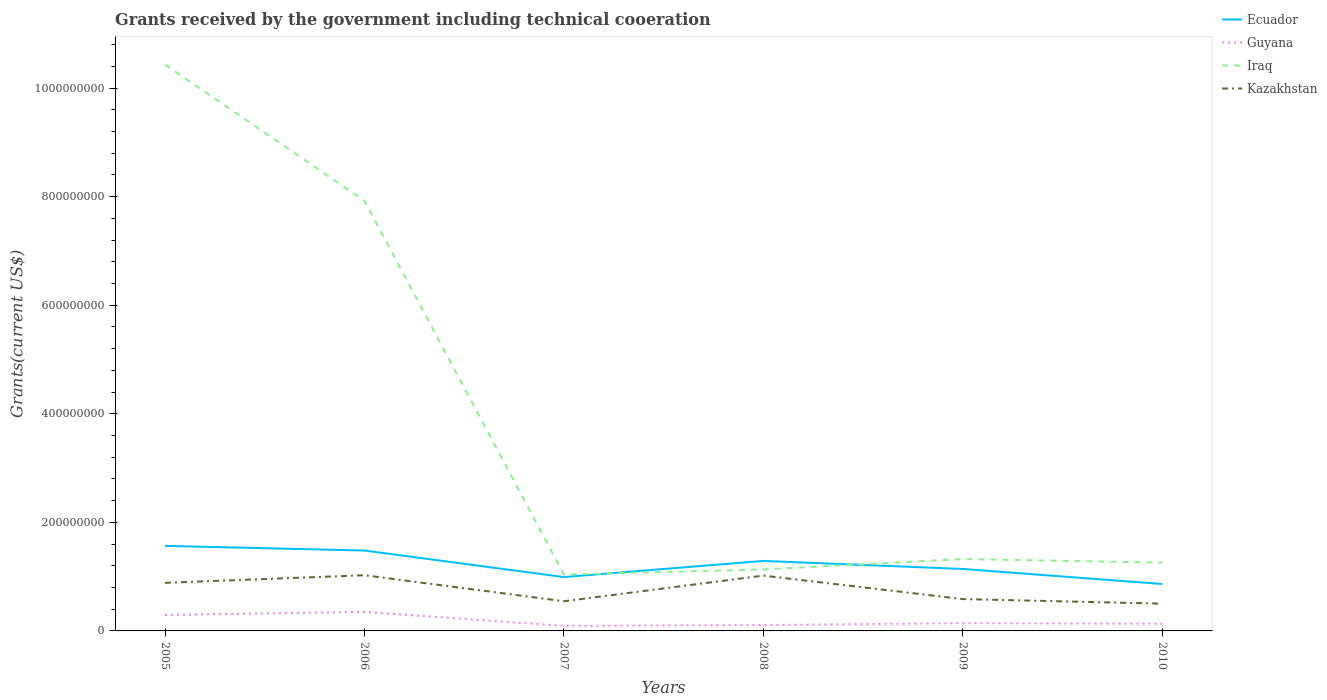How many different coloured lines are there?
Give a very brief answer. 4. Is the number of lines equal to the number of legend labels?
Ensure brevity in your answer.  Yes. Across all years, what is the maximum total grants received by the government in Iraq?
Offer a terse response. 1.04e+08. What is the total total grants received by the government in Ecuador in the graph?
Offer a terse response. 1.48e+07. What is the difference between the highest and the second highest total grants received by the government in Ecuador?
Offer a terse response. 7.02e+07. How many years are there in the graph?
Ensure brevity in your answer.  6. What is the difference between two consecutive major ticks on the Y-axis?
Provide a short and direct response. 2.00e+08. Are the values on the major ticks of Y-axis written in scientific E-notation?
Make the answer very short. No. Does the graph contain any zero values?
Your answer should be very brief. No. Does the graph contain grids?
Offer a very short reply. No. How many legend labels are there?
Keep it short and to the point. 4. How are the legend labels stacked?
Offer a very short reply. Vertical. What is the title of the graph?
Offer a very short reply. Grants received by the government including technical cooeration. Does "Macedonia" appear as one of the legend labels in the graph?
Your response must be concise. No. What is the label or title of the Y-axis?
Your answer should be compact. Grants(current US$). What is the Grants(current US$) in Ecuador in 2005?
Your answer should be very brief. 1.57e+08. What is the Grants(current US$) in Guyana in 2005?
Provide a succinct answer. 2.94e+07. What is the Grants(current US$) in Iraq in 2005?
Keep it short and to the point. 1.04e+09. What is the Grants(current US$) in Kazakhstan in 2005?
Make the answer very short. 8.86e+07. What is the Grants(current US$) of Ecuador in 2006?
Provide a succinct answer. 1.48e+08. What is the Grants(current US$) in Guyana in 2006?
Offer a very short reply. 3.50e+07. What is the Grants(current US$) of Iraq in 2006?
Offer a terse response. 7.92e+08. What is the Grants(current US$) of Kazakhstan in 2006?
Your answer should be very brief. 1.03e+08. What is the Grants(current US$) in Ecuador in 2007?
Offer a very short reply. 9.92e+07. What is the Grants(current US$) of Guyana in 2007?
Make the answer very short. 9.26e+06. What is the Grants(current US$) of Iraq in 2007?
Provide a succinct answer. 1.04e+08. What is the Grants(current US$) of Kazakhstan in 2007?
Offer a terse response. 5.46e+07. What is the Grants(current US$) in Ecuador in 2008?
Your answer should be very brief. 1.29e+08. What is the Grants(current US$) of Guyana in 2008?
Provide a succinct answer. 1.08e+07. What is the Grants(current US$) in Iraq in 2008?
Your response must be concise. 1.13e+08. What is the Grants(current US$) in Kazakhstan in 2008?
Your answer should be very brief. 1.02e+08. What is the Grants(current US$) of Ecuador in 2009?
Provide a short and direct response. 1.14e+08. What is the Grants(current US$) in Guyana in 2009?
Your answer should be compact. 1.42e+07. What is the Grants(current US$) in Iraq in 2009?
Your answer should be very brief. 1.32e+08. What is the Grants(current US$) of Kazakhstan in 2009?
Ensure brevity in your answer.  5.87e+07. What is the Grants(current US$) in Ecuador in 2010?
Offer a terse response. 8.64e+07. What is the Grants(current US$) of Guyana in 2010?
Keep it short and to the point. 1.32e+07. What is the Grants(current US$) of Iraq in 2010?
Your answer should be very brief. 1.26e+08. What is the Grants(current US$) of Kazakhstan in 2010?
Your answer should be compact. 5.02e+07. Across all years, what is the maximum Grants(current US$) of Ecuador?
Provide a short and direct response. 1.57e+08. Across all years, what is the maximum Grants(current US$) in Guyana?
Your answer should be very brief. 3.50e+07. Across all years, what is the maximum Grants(current US$) of Iraq?
Offer a very short reply. 1.04e+09. Across all years, what is the maximum Grants(current US$) of Kazakhstan?
Your answer should be compact. 1.03e+08. Across all years, what is the minimum Grants(current US$) of Ecuador?
Give a very brief answer. 8.64e+07. Across all years, what is the minimum Grants(current US$) of Guyana?
Offer a terse response. 9.26e+06. Across all years, what is the minimum Grants(current US$) in Iraq?
Give a very brief answer. 1.04e+08. Across all years, what is the minimum Grants(current US$) of Kazakhstan?
Give a very brief answer. 5.02e+07. What is the total Grants(current US$) in Ecuador in the graph?
Provide a short and direct response. 7.33e+08. What is the total Grants(current US$) of Guyana in the graph?
Your answer should be very brief. 1.12e+08. What is the total Grants(current US$) in Iraq in the graph?
Make the answer very short. 2.31e+09. What is the total Grants(current US$) of Kazakhstan in the graph?
Your answer should be compact. 4.57e+08. What is the difference between the Grants(current US$) in Ecuador in 2005 and that in 2006?
Offer a very short reply. 8.58e+06. What is the difference between the Grants(current US$) in Guyana in 2005 and that in 2006?
Give a very brief answer. -5.61e+06. What is the difference between the Grants(current US$) in Iraq in 2005 and that in 2006?
Offer a terse response. 2.51e+08. What is the difference between the Grants(current US$) in Kazakhstan in 2005 and that in 2006?
Keep it short and to the point. -1.40e+07. What is the difference between the Grants(current US$) in Ecuador in 2005 and that in 2007?
Ensure brevity in your answer.  5.75e+07. What is the difference between the Grants(current US$) of Guyana in 2005 and that in 2007?
Keep it short and to the point. 2.02e+07. What is the difference between the Grants(current US$) in Iraq in 2005 and that in 2007?
Keep it short and to the point. 9.39e+08. What is the difference between the Grants(current US$) in Kazakhstan in 2005 and that in 2007?
Your answer should be compact. 3.39e+07. What is the difference between the Grants(current US$) of Ecuador in 2005 and that in 2008?
Your response must be concise. 2.77e+07. What is the difference between the Grants(current US$) in Guyana in 2005 and that in 2008?
Provide a succinct answer. 1.86e+07. What is the difference between the Grants(current US$) of Iraq in 2005 and that in 2008?
Provide a short and direct response. 9.30e+08. What is the difference between the Grants(current US$) of Kazakhstan in 2005 and that in 2008?
Your answer should be very brief. -1.33e+07. What is the difference between the Grants(current US$) of Ecuador in 2005 and that in 2009?
Offer a very short reply. 4.25e+07. What is the difference between the Grants(current US$) in Guyana in 2005 and that in 2009?
Keep it short and to the point. 1.52e+07. What is the difference between the Grants(current US$) of Iraq in 2005 and that in 2009?
Your answer should be very brief. 9.11e+08. What is the difference between the Grants(current US$) of Kazakhstan in 2005 and that in 2009?
Provide a succinct answer. 2.99e+07. What is the difference between the Grants(current US$) in Ecuador in 2005 and that in 2010?
Ensure brevity in your answer.  7.02e+07. What is the difference between the Grants(current US$) of Guyana in 2005 and that in 2010?
Make the answer very short. 1.62e+07. What is the difference between the Grants(current US$) in Iraq in 2005 and that in 2010?
Provide a succinct answer. 9.17e+08. What is the difference between the Grants(current US$) in Kazakhstan in 2005 and that in 2010?
Offer a very short reply. 3.83e+07. What is the difference between the Grants(current US$) of Ecuador in 2006 and that in 2007?
Your answer should be compact. 4.89e+07. What is the difference between the Grants(current US$) in Guyana in 2006 and that in 2007?
Your answer should be very brief. 2.58e+07. What is the difference between the Grants(current US$) of Iraq in 2006 and that in 2007?
Provide a short and direct response. 6.88e+08. What is the difference between the Grants(current US$) of Kazakhstan in 2006 and that in 2007?
Your answer should be very brief. 4.80e+07. What is the difference between the Grants(current US$) in Ecuador in 2006 and that in 2008?
Your response must be concise. 1.91e+07. What is the difference between the Grants(current US$) of Guyana in 2006 and that in 2008?
Ensure brevity in your answer.  2.42e+07. What is the difference between the Grants(current US$) of Iraq in 2006 and that in 2008?
Offer a very short reply. 6.79e+08. What is the difference between the Grants(current US$) of Kazakhstan in 2006 and that in 2008?
Provide a succinct answer. 6.80e+05. What is the difference between the Grants(current US$) of Ecuador in 2006 and that in 2009?
Ensure brevity in your answer.  3.40e+07. What is the difference between the Grants(current US$) in Guyana in 2006 and that in 2009?
Offer a terse response. 2.08e+07. What is the difference between the Grants(current US$) of Iraq in 2006 and that in 2009?
Provide a succinct answer. 6.60e+08. What is the difference between the Grants(current US$) in Kazakhstan in 2006 and that in 2009?
Provide a succinct answer. 4.39e+07. What is the difference between the Grants(current US$) in Ecuador in 2006 and that in 2010?
Offer a terse response. 6.16e+07. What is the difference between the Grants(current US$) of Guyana in 2006 and that in 2010?
Your response must be concise. 2.18e+07. What is the difference between the Grants(current US$) in Iraq in 2006 and that in 2010?
Make the answer very short. 6.66e+08. What is the difference between the Grants(current US$) of Kazakhstan in 2006 and that in 2010?
Make the answer very short. 5.24e+07. What is the difference between the Grants(current US$) in Ecuador in 2007 and that in 2008?
Make the answer very short. -2.97e+07. What is the difference between the Grants(current US$) of Guyana in 2007 and that in 2008?
Provide a succinct answer. -1.56e+06. What is the difference between the Grants(current US$) of Iraq in 2007 and that in 2008?
Your response must be concise. -9.33e+06. What is the difference between the Grants(current US$) of Kazakhstan in 2007 and that in 2008?
Your response must be concise. -4.73e+07. What is the difference between the Grants(current US$) of Ecuador in 2007 and that in 2009?
Provide a succinct answer. -1.49e+07. What is the difference between the Grants(current US$) in Guyana in 2007 and that in 2009?
Provide a succinct answer. -4.98e+06. What is the difference between the Grants(current US$) in Iraq in 2007 and that in 2009?
Keep it short and to the point. -2.85e+07. What is the difference between the Grants(current US$) in Kazakhstan in 2007 and that in 2009?
Provide a short and direct response. -4.04e+06. What is the difference between the Grants(current US$) in Ecuador in 2007 and that in 2010?
Make the answer very short. 1.28e+07. What is the difference between the Grants(current US$) of Guyana in 2007 and that in 2010?
Offer a very short reply. -3.94e+06. What is the difference between the Grants(current US$) in Iraq in 2007 and that in 2010?
Keep it short and to the point. -2.19e+07. What is the difference between the Grants(current US$) of Kazakhstan in 2007 and that in 2010?
Make the answer very short. 4.41e+06. What is the difference between the Grants(current US$) in Ecuador in 2008 and that in 2009?
Give a very brief answer. 1.48e+07. What is the difference between the Grants(current US$) in Guyana in 2008 and that in 2009?
Offer a very short reply. -3.42e+06. What is the difference between the Grants(current US$) of Iraq in 2008 and that in 2009?
Ensure brevity in your answer.  -1.92e+07. What is the difference between the Grants(current US$) of Kazakhstan in 2008 and that in 2009?
Give a very brief answer. 4.32e+07. What is the difference between the Grants(current US$) of Ecuador in 2008 and that in 2010?
Ensure brevity in your answer.  4.25e+07. What is the difference between the Grants(current US$) of Guyana in 2008 and that in 2010?
Give a very brief answer. -2.38e+06. What is the difference between the Grants(current US$) of Iraq in 2008 and that in 2010?
Give a very brief answer. -1.25e+07. What is the difference between the Grants(current US$) of Kazakhstan in 2008 and that in 2010?
Make the answer very short. 5.17e+07. What is the difference between the Grants(current US$) in Ecuador in 2009 and that in 2010?
Offer a very short reply. 2.77e+07. What is the difference between the Grants(current US$) of Guyana in 2009 and that in 2010?
Provide a succinct answer. 1.04e+06. What is the difference between the Grants(current US$) of Iraq in 2009 and that in 2010?
Provide a short and direct response. 6.61e+06. What is the difference between the Grants(current US$) of Kazakhstan in 2009 and that in 2010?
Ensure brevity in your answer.  8.45e+06. What is the difference between the Grants(current US$) in Ecuador in 2005 and the Grants(current US$) in Guyana in 2006?
Give a very brief answer. 1.22e+08. What is the difference between the Grants(current US$) of Ecuador in 2005 and the Grants(current US$) of Iraq in 2006?
Your answer should be very brief. -6.36e+08. What is the difference between the Grants(current US$) in Ecuador in 2005 and the Grants(current US$) in Kazakhstan in 2006?
Your answer should be compact. 5.41e+07. What is the difference between the Grants(current US$) of Guyana in 2005 and the Grants(current US$) of Iraq in 2006?
Offer a terse response. -7.63e+08. What is the difference between the Grants(current US$) of Guyana in 2005 and the Grants(current US$) of Kazakhstan in 2006?
Ensure brevity in your answer.  -7.32e+07. What is the difference between the Grants(current US$) of Iraq in 2005 and the Grants(current US$) of Kazakhstan in 2006?
Provide a short and direct response. 9.40e+08. What is the difference between the Grants(current US$) of Ecuador in 2005 and the Grants(current US$) of Guyana in 2007?
Give a very brief answer. 1.47e+08. What is the difference between the Grants(current US$) in Ecuador in 2005 and the Grants(current US$) in Iraq in 2007?
Your answer should be compact. 5.27e+07. What is the difference between the Grants(current US$) in Ecuador in 2005 and the Grants(current US$) in Kazakhstan in 2007?
Offer a very short reply. 1.02e+08. What is the difference between the Grants(current US$) in Guyana in 2005 and the Grants(current US$) in Iraq in 2007?
Make the answer very short. -7.45e+07. What is the difference between the Grants(current US$) in Guyana in 2005 and the Grants(current US$) in Kazakhstan in 2007?
Give a very brief answer. -2.52e+07. What is the difference between the Grants(current US$) of Iraq in 2005 and the Grants(current US$) of Kazakhstan in 2007?
Give a very brief answer. 9.88e+08. What is the difference between the Grants(current US$) of Ecuador in 2005 and the Grants(current US$) of Guyana in 2008?
Provide a succinct answer. 1.46e+08. What is the difference between the Grants(current US$) in Ecuador in 2005 and the Grants(current US$) in Iraq in 2008?
Provide a short and direct response. 4.34e+07. What is the difference between the Grants(current US$) in Ecuador in 2005 and the Grants(current US$) in Kazakhstan in 2008?
Your response must be concise. 5.48e+07. What is the difference between the Grants(current US$) in Guyana in 2005 and the Grants(current US$) in Iraq in 2008?
Provide a succinct answer. -8.38e+07. What is the difference between the Grants(current US$) of Guyana in 2005 and the Grants(current US$) of Kazakhstan in 2008?
Your answer should be compact. -7.25e+07. What is the difference between the Grants(current US$) in Iraq in 2005 and the Grants(current US$) in Kazakhstan in 2008?
Provide a succinct answer. 9.41e+08. What is the difference between the Grants(current US$) of Ecuador in 2005 and the Grants(current US$) of Guyana in 2009?
Make the answer very short. 1.42e+08. What is the difference between the Grants(current US$) in Ecuador in 2005 and the Grants(current US$) in Iraq in 2009?
Ensure brevity in your answer.  2.42e+07. What is the difference between the Grants(current US$) of Ecuador in 2005 and the Grants(current US$) of Kazakhstan in 2009?
Your answer should be very brief. 9.80e+07. What is the difference between the Grants(current US$) in Guyana in 2005 and the Grants(current US$) in Iraq in 2009?
Offer a terse response. -1.03e+08. What is the difference between the Grants(current US$) in Guyana in 2005 and the Grants(current US$) in Kazakhstan in 2009?
Make the answer very short. -2.92e+07. What is the difference between the Grants(current US$) in Iraq in 2005 and the Grants(current US$) in Kazakhstan in 2009?
Your response must be concise. 9.84e+08. What is the difference between the Grants(current US$) in Ecuador in 2005 and the Grants(current US$) in Guyana in 2010?
Keep it short and to the point. 1.43e+08. What is the difference between the Grants(current US$) of Ecuador in 2005 and the Grants(current US$) of Iraq in 2010?
Your response must be concise. 3.09e+07. What is the difference between the Grants(current US$) in Ecuador in 2005 and the Grants(current US$) in Kazakhstan in 2010?
Your response must be concise. 1.06e+08. What is the difference between the Grants(current US$) in Guyana in 2005 and the Grants(current US$) in Iraq in 2010?
Your answer should be compact. -9.64e+07. What is the difference between the Grants(current US$) of Guyana in 2005 and the Grants(current US$) of Kazakhstan in 2010?
Give a very brief answer. -2.08e+07. What is the difference between the Grants(current US$) in Iraq in 2005 and the Grants(current US$) in Kazakhstan in 2010?
Keep it short and to the point. 9.93e+08. What is the difference between the Grants(current US$) in Ecuador in 2006 and the Grants(current US$) in Guyana in 2007?
Your answer should be very brief. 1.39e+08. What is the difference between the Grants(current US$) in Ecuador in 2006 and the Grants(current US$) in Iraq in 2007?
Provide a short and direct response. 4.42e+07. What is the difference between the Grants(current US$) of Ecuador in 2006 and the Grants(current US$) of Kazakhstan in 2007?
Your response must be concise. 9.34e+07. What is the difference between the Grants(current US$) in Guyana in 2006 and the Grants(current US$) in Iraq in 2007?
Provide a short and direct response. -6.89e+07. What is the difference between the Grants(current US$) of Guyana in 2006 and the Grants(current US$) of Kazakhstan in 2007?
Give a very brief answer. -1.96e+07. What is the difference between the Grants(current US$) in Iraq in 2006 and the Grants(current US$) in Kazakhstan in 2007?
Give a very brief answer. 7.38e+08. What is the difference between the Grants(current US$) in Ecuador in 2006 and the Grants(current US$) in Guyana in 2008?
Keep it short and to the point. 1.37e+08. What is the difference between the Grants(current US$) in Ecuador in 2006 and the Grants(current US$) in Iraq in 2008?
Ensure brevity in your answer.  3.48e+07. What is the difference between the Grants(current US$) in Ecuador in 2006 and the Grants(current US$) in Kazakhstan in 2008?
Offer a terse response. 4.62e+07. What is the difference between the Grants(current US$) of Guyana in 2006 and the Grants(current US$) of Iraq in 2008?
Provide a succinct answer. -7.82e+07. What is the difference between the Grants(current US$) in Guyana in 2006 and the Grants(current US$) in Kazakhstan in 2008?
Offer a terse response. -6.69e+07. What is the difference between the Grants(current US$) in Iraq in 2006 and the Grants(current US$) in Kazakhstan in 2008?
Your answer should be compact. 6.90e+08. What is the difference between the Grants(current US$) of Ecuador in 2006 and the Grants(current US$) of Guyana in 2009?
Provide a succinct answer. 1.34e+08. What is the difference between the Grants(current US$) of Ecuador in 2006 and the Grants(current US$) of Iraq in 2009?
Provide a short and direct response. 1.57e+07. What is the difference between the Grants(current US$) of Ecuador in 2006 and the Grants(current US$) of Kazakhstan in 2009?
Your answer should be compact. 8.94e+07. What is the difference between the Grants(current US$) of Guyana in 2006 and the Grants(current US$) of Iraq in 2009?
Provide a succinct answer. -9.74e+07. What is the difference between the Grants(current US$) of Guyana in 2006 and the Grants(current US$) of Kazakhstan in 2009?
Offer a terse response. -2.36e+07. What is the difference between the Grants(current US$) of Iraq in 2006 and the Grants(current US$) of Kazakhstan in 2009?
Offer a terse response. 7.34e+08. What is the difference between the Grants(current US$) of Ecuador in 2006 and the Grants(current US$) of Guyana in 2010?
Your answer should be very brief. 1.35e+08. What is the difference between the Grants(current US$) in Ecuador in 2006 and the Grants(current US$) in Iraq in 2010?
Provide a succinct answer. 2.23e+07. What is the difference between the Grants(current US$) in Ecuador in 2006 and the Grants(current US$) in Kazakhstan in 2010?
Your response must be concise. 9.78e+07. What is the difference between the Grants(current US$) of Guyana in 2006 and the Grants(current US$) of Iraq in 2010?
Ensure brevity in your answer.  -9.08e+07. What is the difference between the Grants(current US$) in Guyana in 2006 and the Grants(current US$) in Kazakhstan in 2010?
Your answer should be very brief. -1.52e+07. What is the difference between the Grants(current US$) of Iraq in 2006 and the Grants(current US$) of Kazakhstan in 2010?
Make the answer very short. 7.42e+08. What is the difference between the Grants(current US$) in Ecuador in 2007 and the Grants(current US$) in Guyana in 2008?
Your answer should be compact. 8.84e+07. What is the difference between the Grants(current US$) of Ecuador in 2007 and the Grants(current US$) of Iraq in 2008?
Ensure brevity in your answer.  -1.41e+07. What is the difference between the Grants(current US$) in Ecuador in 2007 and the Grants(current US$) in Kazakhstan in 2008?
Provide a short and direct response. -2.71e+06. What is the difference between the Grants(current US$) of Guyana in 2007 and the Grants(current US$) of Iraq in 2008?
Your response must be concise. -1.04e+08. What is the difference between the Grants(current US$) of Guyana in 2007 and the Grants(current US$) of Kazakhstan in 2008?
Make the answer very short. -9.26e+07. What is the difference between the Grants(current US$) of Iraq in 2007 and the Grants(current US$) of Kazakhstan in 2008?
Ensure brevity in your answer.  2.02e+06. What is the difference between the Grants(current US$) of Ecuador in 2007 and the Grants(current US$) of Guyana in 2009?
Offer a terse response. 8.50e+07. What is the difference between the Grants(current US$) of Ecuador in 2007 and the Grants(current US$) of Iraq in 2009?
Provide a short and direct response. -3.32e+07. What is the difference between the Grants(current US$) in Ecuador in 2007 and the Grants(current US$) in Kazakhstan in 2009?
Make the answer very short. 4.05e+07. What is the difference between the Grants(current US$) of Guyana in 2007 and the Grants(current US$) of Iraq in 2009?
Ensure brevity in your answer.  -1.23e+08. What is the difference between the Grants(current US$) of Guyana in 2007 and the Grants(current US$) of Kazakhstan in 2009?
Offer a very short reply. -4.94e+07. What is the difference between the Grants(current US$) of Iraq in 2007 and the Grants(current US$) of Kazakhstan in 2009?
Offer a terse response. 4.52e+07. What is the difference between the Grants(current US$) in Ecuador in 2007 and the Grants(current US$) in Guyana in 2010?
Offer a terse response. 8.60e+07. What is the difference between the Grants(current US$) of Ecuador in 2007 and the Grants(current US$) of Iraq in 2010?
Offer a very short reply. -2.66e+07. What is the difference between the Grants(current US$) of Ecuador in 2007 and the Grants(current US$) of Kazakhstan in 2010?
Offer a terse response. 4.90e+07. What is the difference between the Grants(current US$) in Guyana in 2007 and the Grants(current US$) in Iraq in 2010?
Make the answer very short. -1.17e+08. What is the difference between the Grants(current US$) in Guyana in 2007 and the Grants(current US$) in Kazakhstan in 2010?
Your answer should be compact. -4.10e+07. What is the difference between the Grants(current US$) in Iraq in 2007 and the Grants(current US$) in Kazakhstan in 2010?
Your response must be concise. 5.37e+07. What is the difference between the Grants(current US$) in Ecuador in 2008 and the Grants(current US$) in Guyana in 2009?
Offer a very short reply. 1.15e+08. What is the difference between the Grants(current US$) of Ecuador in 2008 and the Grants(current US$) of Iraq in 2009?
Offer a terse response. -3.47e+06. What is the difference between the Grants(current US$) in Ecuador in 2008 and the Grants(current US$) in Kazakhstan in 2009?
Offer a very short reply. 7.03e+07. What is the difference between the Grants(current US$) of Guyana in 2008 and the Grants(current US$) of Iraq in 2009?
Give a very brief answer. -1.22e+08. What is the difference between the Grants(current US$) of Guyana in 2008 and the Grants(current US$) of Kazakhstan in 2009?
Your answer should be very brief. -4.78e+07. What is the difference between the Grants(current US$) of Iraq in 2008 and the Grants(current US$) of Kazakhstan in 2009?
Make the answer very short. 5.46e+07. What is the difference between the Grants(current US$) in Ecuador in 2008 and the Grants(current US$) in Guyana in 2010?
Your response must be concise. 1.16e+08. What is the difference between the Grants(current US$) of Ecuador in 2008 and the Grants(current US$) of Iraq in 2010?
Your response must be concise. 3.14e+06. What is the difference between the Grants(current US$) of Ecuador in 2008 and the Grants(current US$) of Kazakhstan in 2010?
Offer a very short reply. 7.87e+07. What is the difference between the Grants(current US$) of Guyana in 2008 and the Grants(current US$) of Iraq in 2010?
Your answer should be very brief. -1.15e+08. What is the difference between the Grants(current US$) in Guyana in 2008 and the Grants(current US$) in Kazakhstan in 2010?
Keep it short and to the point. -3.94e+07. What is the difference between the Grants(current US$) of Iraq in 2008 and the Grants(current US$) of Kazakhstan in 2010?
Ensure brevity in your answer.  6.30e+07. What is the difference between the Grants(current US$) of Ecuador in 2009 and the Grants(current US$) of Guyana in 2010?
Make the answer very short. 1.01e+08. What is the difference between the Grants(current US$) in Ecuador in 2009 and the Grants(current US$) in Iraq in 2010?
Offer a very short reply. -1.17e+07. What is the difference between the Grants(current US$) in Ecuador in 2009 and the Grants(current US$) in Kazakhstan in 2010?
Offer a terse response. 6.39e+07. What is the difference between the Grants(current US$) in Guyana in 2009 and the Grants(current US$) in Iraq in 2010?
Give a very brief answer. -1.12e+08. What is the difference between the Grants(current US$) in Guyana in 2009 and the Grants(current US$) in Kazakhstan in 2010?
Ensure brevity in your answer.  -3.60e+07. What is the difference between the Grants(current US$) in Iraq in 2009 and the Grants(current US$) in Kazakhstan in 2010?
Keep it short and to the point. 8.22e+07. What is the average Grants(current US$) of Ecuador per year?
Give a very brief answer. 1.22e+08. What is the average Grants(current US$) of Guyana per year?
Give a very brief answer. 1.87e+07. What is the average Grants(current US$) in Iraq per year?
Your response must be concise. 3.85e+08. What is the average Grants(current US$) of Kazakhstan per year?
Give a very brief answer. 7.61e+07. In the year 2005, what is the difference between the Grants(current US$) of Ecuador and Grants(current US$) of Guyana?
Offer a very short reply. 1.27e+08. In the year 2005, what is the difference between the Grants(current US$) in Ecuador and Grants(current US$) in Iraq?
Your answer should be compact. -8.86e+08. In the year 2005, what is the difference between the Grants(current US$) in Ecuador and Grants(current US$) in Kazakhstan?
Your answer should be compact. 6.81e+07. In the year 2005, what is the difference between the Grants(current US$) in Guyana and Grants(current US$) in Iraq?
Your answer should be compact. -1.01e+09. In the year 2005, what is the difference between the Grants(current US$) in Guyana and Grants(current US$) in Kazakhstan?
Provide a succinct answer. -5.91e+07. In the year 2005, what is the difference between the Grants(current US$) of Iraq and Grants(current US$) of Kazakhstan?
Offer a terse response. 9.54e+08. In the year 2006, what is the difference between the Grants(current US$) in Ecuador and Grants(current US$) in Guyana?
Provide a succinct answer. 1.13e+08. In the year 2006, what is the difference between the Grants(current US$) in Ecuador and Grants(current US$) in Iraq?
Give a very brief answer. -6.44e+08. In the year 2006, what is the difference between the Grants(current US$) of Ecuador and Grants(current US$) of Kazakhstan?
Your answer should be very brief. 4.55e+07. In the year 2006, what is the difference between the Grants(current US$) of Guyana and Grants(current US$) of Iraq?
Offer a terse response. -7.57e+08. In the year 2006, what is the difference between the Grants(current US$) of Guyana and Grants(current US$) of Kazakhstan?
Provide a short and direct response. -6.75e+07. In the year 2006, what is the difference between the Grants(current US$) of Iraq and Grants(current US$) of Kazakhstan?
Offer a very short reply. 6.90e+08. In the year 2007, what is the difference between the Grants(current US$) of Ecuador and Grants(current US$) of Guyana?
Offer a terse response. 8.99e+07. In the year 2007, what is the difference between the Grants(current US$) in Ecuador and Grants(current US$) in Iraq?
Your answer should be compact. -4.73e+06. In the year 2007, what is the difference between the Grants(current US$) in Ecuador and Grants(current US$) in Kazakhstan?
Make the answer very short. 4.46e+07. In the year 2007, what is the difference between the Grants(current US$) in Guyana and Grants(current US$) in Iraq?
Provide a short and direct response. -9.47e+07. In the year 2007, what is the difference between the Grants(current US$) in Guyana and Grants(current US$) in Kazakhstan?
Make the answer very short. -4.54e+07. In the year 2007, what is the difference between the Grants(current US$) in Iraq and Grants(current US$) in Kazakhstan?
Offer a terse response. 4.93e+07. In the year 2008, what is the difference between the Grants(current US$) of Ecuador and Grants(current US$) of Guyana?
Provide a short and direct response. 1.18e+08. In the year 2008, what is the difference between the Grants(current US$) in Ecuador and Grants(current US$) in Iraq?
Provide a succinct answer. 1.57e+07. In the year 2008, what is the difference between the Grants(current US$) of Ecuador and Grants(current US$) of Kazakhstan?
Offer a terse response. 2.70e+07. In the year 2008, what is the difference between the Grants(current US$) of Guyana and Grants(current US$) of Iraq?
Provide a succinct answer. -1.02e+08. In the year 2008, what is the difference between the Grants(current US$) in Guyana and Grants(current US$) in Kazakhstan?
Offer a very short reply. -9.11e+07. In the year 2008, what is the difference between the Grants(current US$) in Iraq and Grants(current US$) in Kazakhstan?
Offer a very short reply. 1.14e+07. In the year 2009, what is the difference between the Grants(current US$) of Ecuador and Grants(current US$) of Guyana?
Keep it short and to the point. 9.99e+07. In the year 2009, what is the difference between the Grants(current US$) in Ecuador and Grants(current US$) in Iraq?
Ensure brevity in your answer.  -1.83e+07. In the year 2009, what is the difference between the Grants(current US$) in Ecuador and Grants(current US$) in Kazakhstan?
Offer a very short reply. 5.54e+07. In the year 2009, what is the difference between the Grants(current US$) in Guyana and Grants(current US$) in Iraq?
Your response must be concise. -1.18e+08. In the year 2009, what is the difference between the Grants(current US$) of Guyana and Grants(current US$) of Kazakhstan?
Offer a very short reply. -4.44e+07. In the year 2009, what is the difference between the Grants(current US$) in Iraq and Grants(current US$) in Kazakhstan?
Give a very brief answer. 7.37e+07. In the year 2010, what is the difference between the Grants(current US$) in Ecuador and Grants(current US$) in Guyana?
Your response must be concise. 7.32e+07. In the year 2010, what is the difference between the Grants(current US$) in Ecuador and Grants(current US$) in Iraq?
Give a very brief answer. -3.94e+07. In the year 2010, what is the difference between the Grants(current US$) of Ecuador and Grants(current US$) of Kazakhstan?
Provide a succinct answer. 3.62e+07. In the year 2010, what is the difference between the Grants(current US$) of Guyana and Grants(current US$) of Iraq?
Your response must be concise. -1.13e+08. In the year 2010, what is the difference between the Grants(current US$) of Guyana and Grants(current US$) of Kazakhstan?
Your response must be concise. -3.70e+07. In the year 2010, what is the difference between the Grants(current US$) in Iraq and Grants(current US$) in Kazakhstan?
Keep it short and to the point. 7.56e+07. What is the ratio of the Grants(current US$) of Ecuador in 2005 to that in 2006?
Provide a short and direct response. 1.06. What is the ratio of the Grants(current US$) of Guyana in 2005 to that in 2006?
Make the answer very short. 0.84. What is the ratio of the Grants(current US$) of Iraq in 2005 to that in 2006?
Provide a succinct answer. 1.32. What is the ratio of the Grants(current US$) of Kazakhstan in 2005 to that in 2006?
Your response must be concise. 0.86. What is the ratio of the Grants(current US$) in Ecuador in 2005 to that in 2007?
Make the answer very short. 1.58. What is the ratio of the Grants(current US$) in Guyana in 2005 to that in 2007?
Your answer should be very brief. 3.18. What is the ratio of the Grants(current US$) of Iraq in 2005 to that in 2007?
Offer a very short reply. 10.04. What is the ratio of the Grants(current US$) in Kazakhstan in 2005 to that in 2007?
Your answer should be compact. 1.62. What is the ratio of the Grants(current US$) in Ecuador in 2005 to that in 2008?
Your answer should be very brief. 1.22. What is the ratio of the Grants(current US$) in Guyana in 2005 to that in 2008?
Offer a terse response. 2.72. What is the ratio of the Grants(current US$) of Iraq in 2005 to that in 2008?
Provide a short and direct response. 9.21. What is the ratio of the Grants(current US$) of Kazakhstan in 2005 to that in 2008?
Offer a terse response. 0.87. What is the ratio of the Grants(current US$) in Ecuador in 2005 to that in 2009?
Give a very brief answer. 1.37. What is the ratio of the Grants(current US$) in Guyana in 2005 to that in 2009?
Ensure brevity in your answer.  2.07. What is the ratio of the Grants(current US$) of Iraq in 2005 to that in 2009?
Give a very brief answer. 7.88. What is the ratio of the Grants(current US$) of Kazakhstan in 2005 to that in 2009?
Offer a very short reply. 1.51. What is the ratio of the Grants(current US$) of Ecuador in 2005 to that in 2010?
Keep it short and to the point. 1.81. What is the ratio of the Grants(current US$) of Guyana in 2005 to that in 2010?
Keep it short and to the point. 2.23. What is the ratio of the Grants(current US$) in Iraq in 2005 to that in 2010?
Give a very brief answer. 8.29. What is the ratio of the Grants(current US$) of Kazakhstan in 2005 to that in 2010?
Offer a very short reply. 1.76. What is the ratio of the Grants(current US$) in Ecuador in 2006 to that in 2007?
Give a very brief answer. 1.49. What is the ratio of the Grants(current US$) of Guyana in 2006 to that in 2007?
Your answer should be very brief. 3.78. What is the ratio of the Grants(current US$) in Iraq in 2006 to that in 2007?
Offer a very short reply. 7.62. What is the ratio of the Grants(current US$) in Kazakhstan in 2006 to that in 2007?
Make the answer very short. 1.88. What is the ratio of the Grants(current US$) of Ecuador in 2006 to that in 2008?
Offer a very short reply. 1.15. What is the ratio of the Grants(current US$) in Guyana in 2006 to that in 2008?
Your answer should be very brief. 3.24. What is the ratio of the Grants(current US$) of Iraq in 2006 to that in 2008?
Ensure brevity in your answer.  7. What is the ratio of the Grants(current US$) in Ecuador in 2006 to that in 2009?
Offer a very short reply. 1.3. What is the ratio of the Grants(current US$) in Guyana in 2006 to that in 2009?
Offer a very short reply. 2.46. What is the ratio of the Grants(current US$) in Iraq in 2006 to that in 2009?
Give a very brief answer. 5.98. What is the ratio of the Grants(current US$) in Kazakhstan in 2006 to that in 2009?
Make the answer very short. 1.75. What is the ratio of the Grants(current US$) in Ecuador in 2006 to that in 2010?
Offer a terse response. 1.71. What is the ratio of the Grants(current US$) of Guyana in 2006 to that in 2010?
Offer a terse response. 2.65. What is the ratio of the Grants(current US$) of Iraq in 2006 to that in 2010?
Offer a terse response. 6.3. What is the ratio of the Grants(current US$) of Kazakhstan in 2006 to that in 2010?
Your answer should be very brief. 2.04. What is the ratio of the Grants(current US$) of Ecuador in 2007 to that in 2008?
Make the answer very short. 0.77. What is the ratio of the Grants(current US$) of Guyana in 2007 to that in 2008?
Offer a terse response. 0.86. What is the ratio of the Grants(current US$) of Iraq in 2007 to that in 2008?
Ensure brevity in your answer.  0.92. What is the ratio of the Grants(current US$) in Kazakhstan in 2007 to that in 2008?
Offer a very short reply. 0.54. What is the ratio of the Grants(current US$) of Ecuador in 2007 to that in 2009?
Keep it short and to the point. 0.87. What is the ratio of the Grants(current US$) in Guyana in 2007 to that in 2009?
Make the answer very short. 0.65. What is the ratio of the Grants(current US$) in Iraq in 2007 to that in 2009?
Your answer should be very brief. 0.78. What is the ratio of the Grants(current US$) of Kazakhstan in 2007 to that in 2009?
Your response must be concise. 0.93. What is the ratio of the Grants(current US$) in Ecuador in 2007 to that in 2010?
Offer a terse response. 1.15. What is the ratio of the Grants(current US$) in Guyana in 2007 to that in 2010?
Your response must be concise. 0.7. What is the ratio of the Grants(current US$) of Iraq in 2007 to that in 2010?
Make the answer very short. 0.83. What is the ratio of the Grants(current US$) in Kazakhstan in 2007 to that in 2010?
Your answer should be very brief. 1.09. What is the ratio of the Grants(current US$) of Ecuador in 2008 to that in 2009?
Give a very brief answer. 1.13. What is the ratio of the Grants(current US$) of Guyana in 2008 to that in 2009?
Your response must be concise. 0.76. What is the ratio of the Grants(current US$) in Iraq in 2008 to that in 2009?
Give a very brief answer. 0.86. What is the ratio of the Grants(current US$) of Kazakhstan in 2008 to that in 2009?
Make the answer very short. 1.74. What is the ratio of the Grants(current US$) in Ecuador in 2008 to that in 2010?
Your answer should be very brief. 1.49. What is the ratio of the Grants(current US$) of Guyana in 2008 to that in 2010?
Keep it short and to the point. 0.82. What is the ratio of the Grants(current US$) of Iraq in 2008 to that in 2010?
Your response must be concise. 0.9. What is the ratio of the Grants(current US$) in Kazakhstan in 2008 to that in 2010?
Your answer should be very brief. 2.03. What is the ratio of the Grants(current US$) in Ecuador in 2009 to that in 2010?
Your answer should be very brief. 1.32. What is the ratio of the Grants(current US$) in Guyana in 2009 to that in 2010?
Provide a short and direct response. 1.08. What is the ratio of the Grants(current US$) of Iraq in 2009 to that in 2010?
Provide a succinct answer. 1.05. What is the ratio of the Grants(current US$) in Kazakhstan in 2009 to that in 2010?
Your answer should be compact. 1.17. What is the difference between the highest and the second highest Grants(current US$) of Ecuador?
Your answer should be very brief. 8.58e+06. What is the difference between the highest and the second highest Grants(current US$) of Guyana?
Provide a short and direct response. 5.61e+06. What is the difference between the highest and the second highest Grants(current US$) in Iraq?
Your answer should be very brief. 2.51e+08. What is the difference between the highest and the second highest Grants(current US$) of Kazakhstan?
Give a very brief answer. 6.80e+05. What is the difference between the highest and the lowest Grants(current US$) of Ecuador?
Keep it short and to the point. 7.02e+07. What is the difference between the highest and the lowest Grants(current US$) in Guyana?
Make the answer very short. 2.58e+07. What is the difference between the highest and the lowest Grants(current US$) in Iraq?
Your response must be concise. 9.39e+08. What is the difference between the highest and the lowest Grants(current US$) in Kazakhstan?
Offer a very short reply. 5.24e+07. 